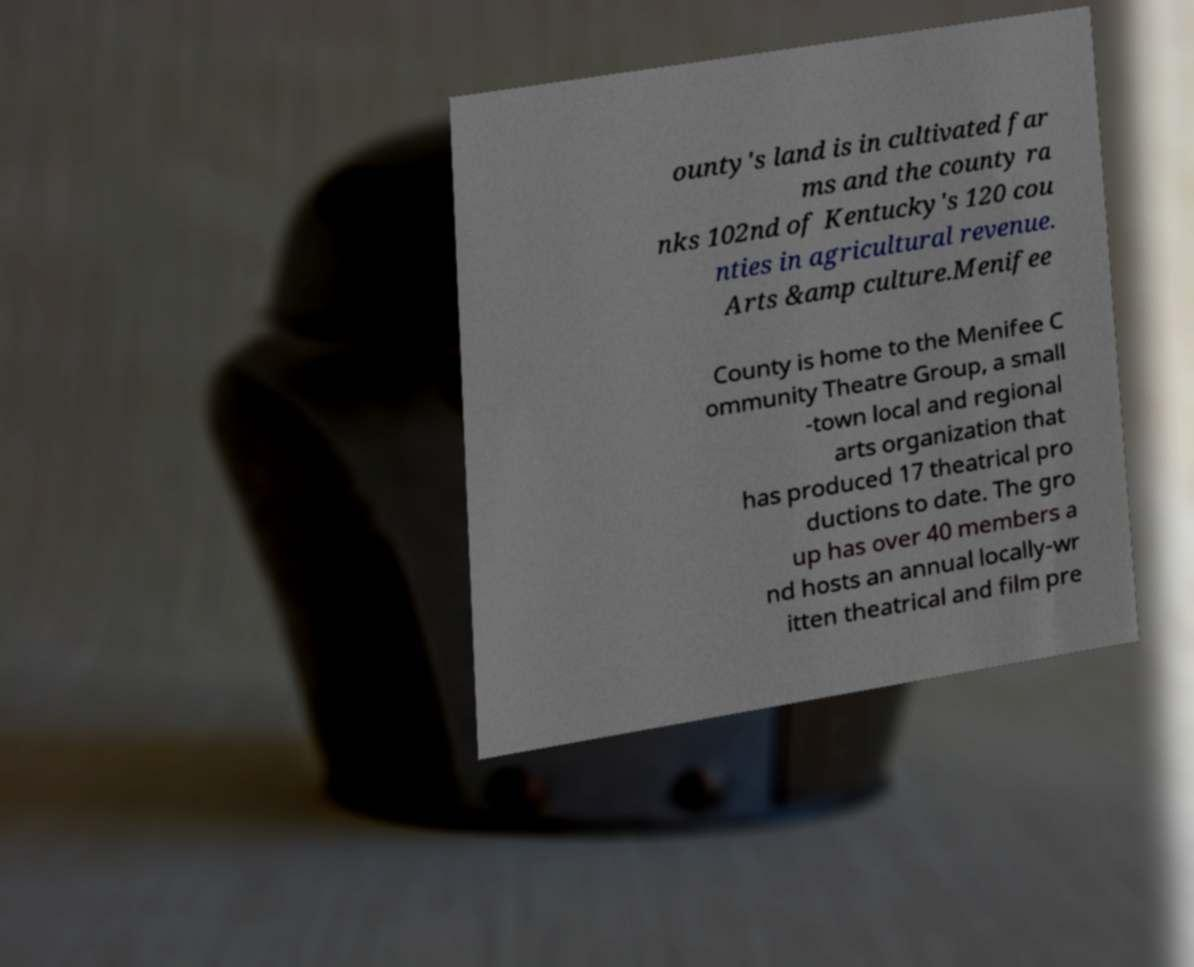Please identify and transcribe the text found in this image. ounty's land is in cultivated far ms and the county ra nks 102nd of Kentucky's 120 cou nties in agricultural revenue. Arts &amp culture.Menifee County is home to the Menifee C ommunity Theatre Group, a small -town local and regional arts organization that has produced 17 theatrical pro ductions to date. The gro up has over 40 members a nd hosts an annual locally-wr itten theatrical and film pre 